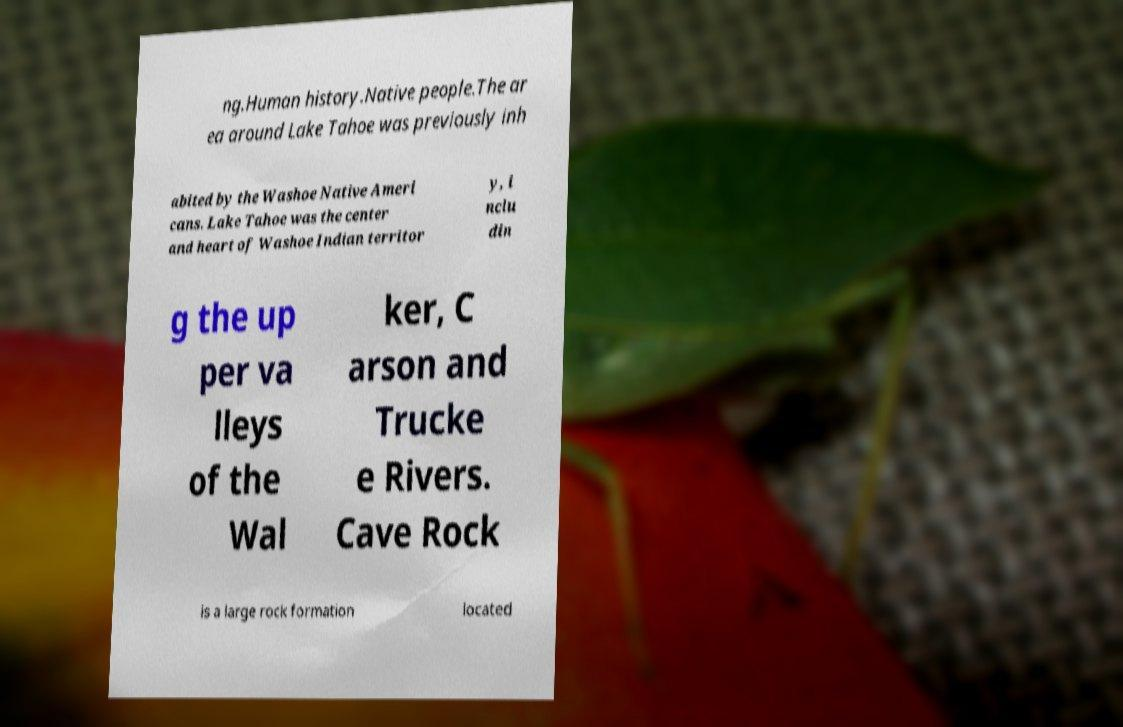There's text embedded in this image that I need extracted. Can you transcribe it verbatim? ng.Human history.Native people.The ar ea around Lake Tahoe was previously inh abited by the Washoe Native Ameri cans. Lake Tahoe was the center and heart of Washoe Indian territor y, i nclu din g the up per va lleys of the Wal ker, C arson and Trucke e Rivers. Cave Rock is a large rock formation located 